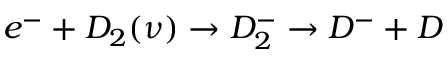Convert formula to latex. <formula><loc_0><loc_0><loc_500><loc_500>e ^ { - } + D _ { 2 } ( \nu ) \rightarrow D _ { 2 } ^ { - } \rightarrow D ^ { - } + D</formula> 